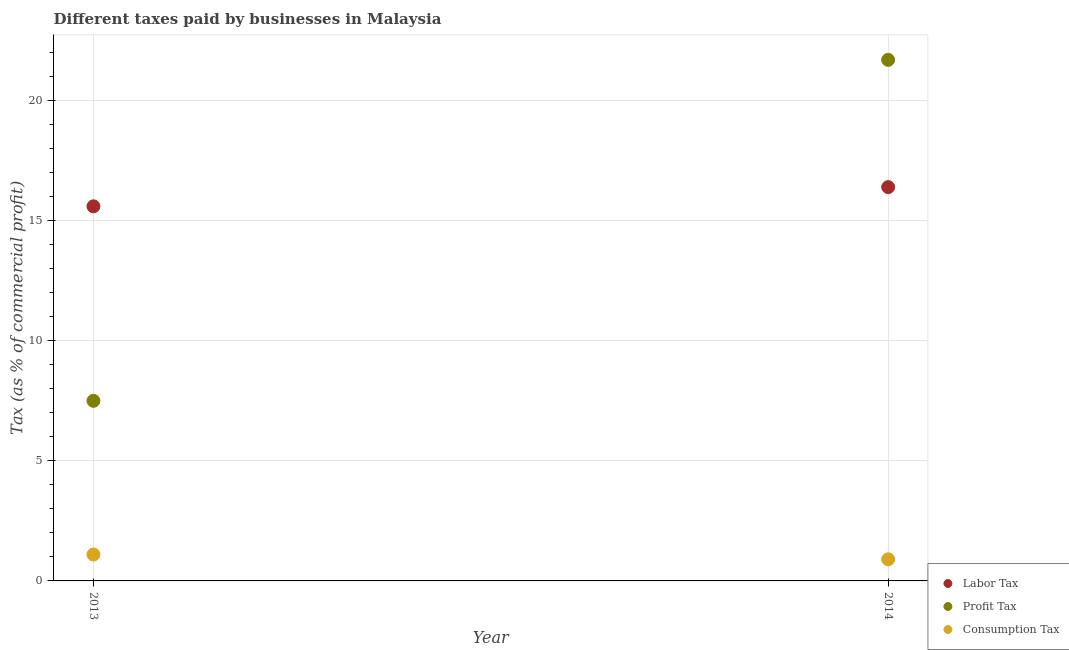Is the number of dotlines equal to the number of legend labels?
Your response must be concise. Yes. What is the percentage of profit tax in 2014?
Provide a succinct answer. 21.7. In which year was the percentage of profit tax maximum?
Offer a terse response. 2014. What is the difference between the percentage of labor tax in 2013 and that in 2014?
Give a very brief answer. -0.8. What is the difference between the percentage of labor tax in 2014 and the percentage of profit tax in 2013?
Offer a very short reply. 8.9. In the year 2013, what is the difference between the percentage of consumption tax and percentage of profit tax?
Ensure brevity in your answer.  -6.4. In how many years, is the percentage of consumption tax greater than 1 %?
Ensure brevity in your answer.  1. What is the ratio of the percentage of consumption tax in 2013 to that in 2014?
Offer a terse response. 1.22. Does the percentage of labor tax monotonically increase over the years?
Keep it short and to the point. Yes. Is the percentage of profit tax strictly greater than the percentage of consumption tax over the years?
Keep it short and to the point. Yes. Is the percentage of consumption tax strictly less than the percentage of profit tax over the years?
Ensure brevity in your answer.  Yes. Are the values on the major ticks of Y-axis written in scientific E-notation?
Keep it short and to the point. No. Does the graph contain any zero values?
Offer a very short reply. No. Where does the legend appear in the graph?
Your response must be concise. Bottom right. How are the legend labels stacked?
Give a very brief answer. Vertical. What is the title of the graph?
Your answer should be very brief. Different taxes paid by businesses in Malaysia. Does "Coal sources" appear as one of the legend labels in the graph?
Provide a succinct answer. No. What is the label or title of the Y-axis?
Ensure brevity in your answer.  Tax (as % of commercial profit). What is the Tax (as % of commercial profit) in Profit Tax in 2013?
Offer a very short reply. 7.5. What is the Tax (as % of commercial profit) of Consumption Tax in 2013?
Provide a succinct answer. 1.1. What is the Tax (as % of commercial profit) of Profit Tax in 2014?
Give a very brief answer. 21.7. Across all years, what is the maximum Tax (as % of commercial profit) of Labor Tax?
Offer a terse response. 16.4. Across all years, what is the maximum Tax (as % of commercial profit) in Profit Tax?
Ensure brevity in your answer.  21.7. What is the total Tax (as % of commercial profit) of Profit Tax in the graph?
Keep it short and to the point. 29.2. What is the difference between the Tax (as % of commercial profit) in Labor Tax in 2013 and that in 2014?
Ensure brevity in your answer.  -0.8. What is the difference between the Tax (as % of commercial profit) in Profit Tax in 2013 and that in 2014?
Offer a very short reply. -14.2. What is the difference between the Tax (as % of commercial profit) of Labor Tax in 2013 and the Tax (as % of commercial profit) of Consumption Tax in 2014?
Your answer should be compact. 14.7. What is the average Tax (as % of commercial profit) of Profit Tax per year?
Your answer should be compact. 14.6. In the year 2014, what is the difference between the Tax (as % of commercial profit) of Profit Tax and Tax (as % of commercial profit) of Consumption Tax?
Your response must be concise. 20.8. What is the ratio of the Tax (as % of commercial profit) in Labor Tax in 2013 to that in 2014?
Ensure brevity in your answer.  0.95. What is the ratio of the Tax (as % of commercial profit) in Profit Tax in 2013 to that in 2014?
Offer a terse response. 0.35. What is the ratio of the Tax (as % of commercial profit) in Consumption Tax in 2013 to that in 2014?
Your answer should be compact. 1.22. What is the difference between the highest and the second highest Tax (as % of commercial profit) of Profit Tax?
Your response must be concise. 14.2. What is the difference between the highest and the second highest Tax (as % of commercial profit) in Consumption Tax?
Give a very brief answer. 0.2. What is the difference between the highest and the lowest Tax (as % of commercial profit) of Consumption Tax?
Offer a terse response. 0.2. 